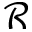<formula> <loc_0><loc_0><loc_500><loc_500>\mathcal { R }</formula> 